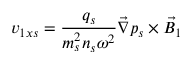Convert formula to latex. <formula><loc_0><loc_0><loc_500><loc_500>v _ { 1 x s } = \frac { q _ { s } } { m _ { s } ^ { 2 } n _ { s } \omega ^ { 2 } } \vec { \nabla } p _ { s } \times \vec { B } _ { 1 }</formula> 